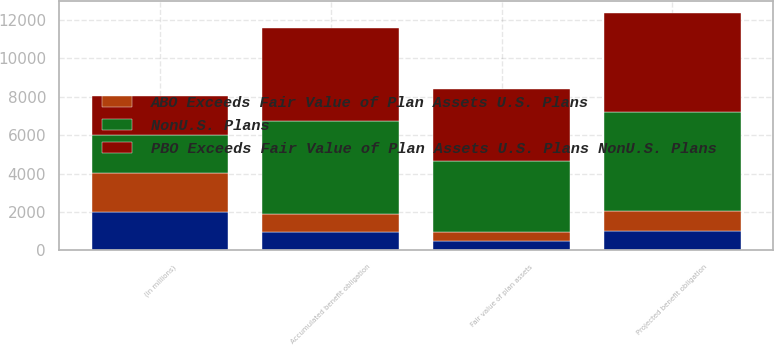Convert chart to OTSL. <chart><loc_0><loc_0><loc_500><loc_500><stacked_bar_chart><ecel><fcel>(in millions)<fcel>Projected benefit obligation<fcel>Accumulated benefit obligation<fcel>Fair value of plan assets<nl><fcel>PBO Exceeds Fair Value of Plan Assets U.S. Plans NonU.S. Plans<fcel>2012<fcel>5161<fcel>4827<fcel>3720<nl><fcel>nan<fcel>2012<fcel>1028<fcel>964<fcel>485<nl><fcel>NonU.S. Plans<fcel>2012<fcel>5161<fcel>4827<fcel>3720<nl><fcel>ABO Exceeds Fair Value of Plan Assets U.S. Plans<fcel>2012<fcel>1018<fcel>959<fcel>478<nl></chart> 